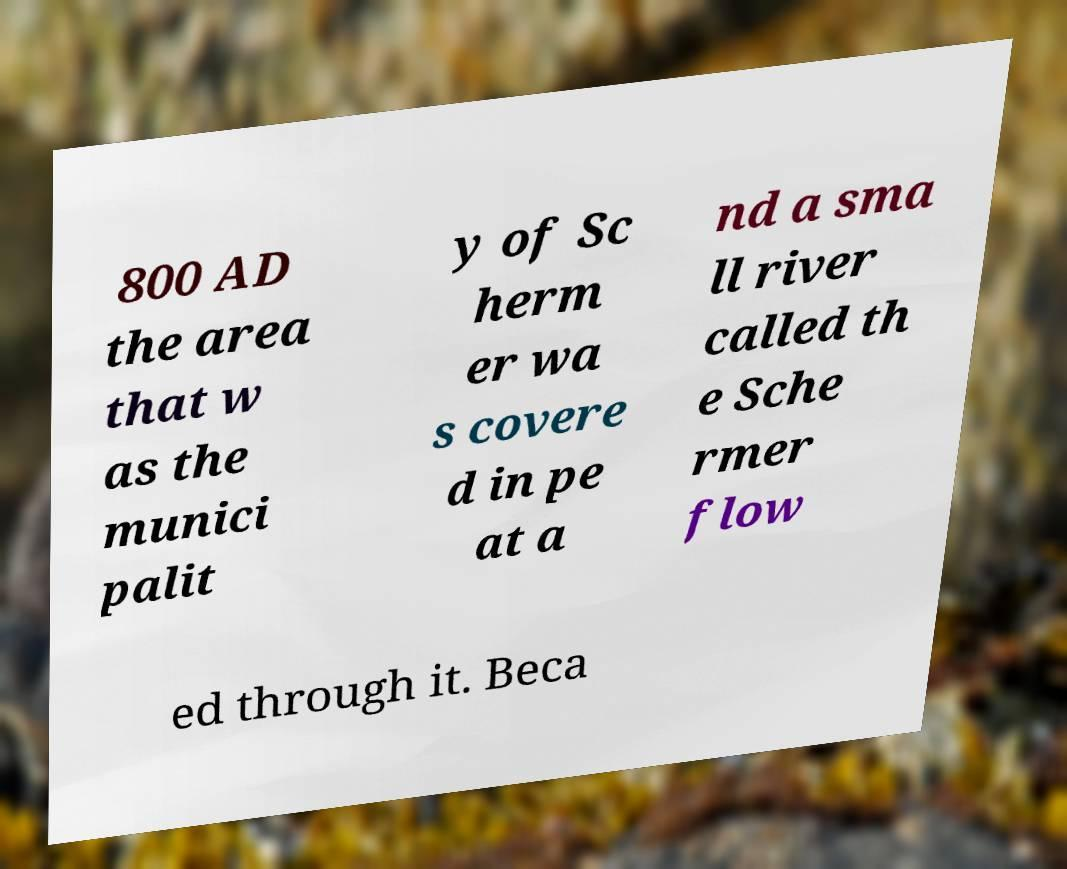Please read and relay the text visible in this image. What does it say? 800 AD the area that w as the munici palit y of Sc herm er wa s covere d in pe at a nd a sma ll river called th e Sche rmer flow ed through it. Beca 